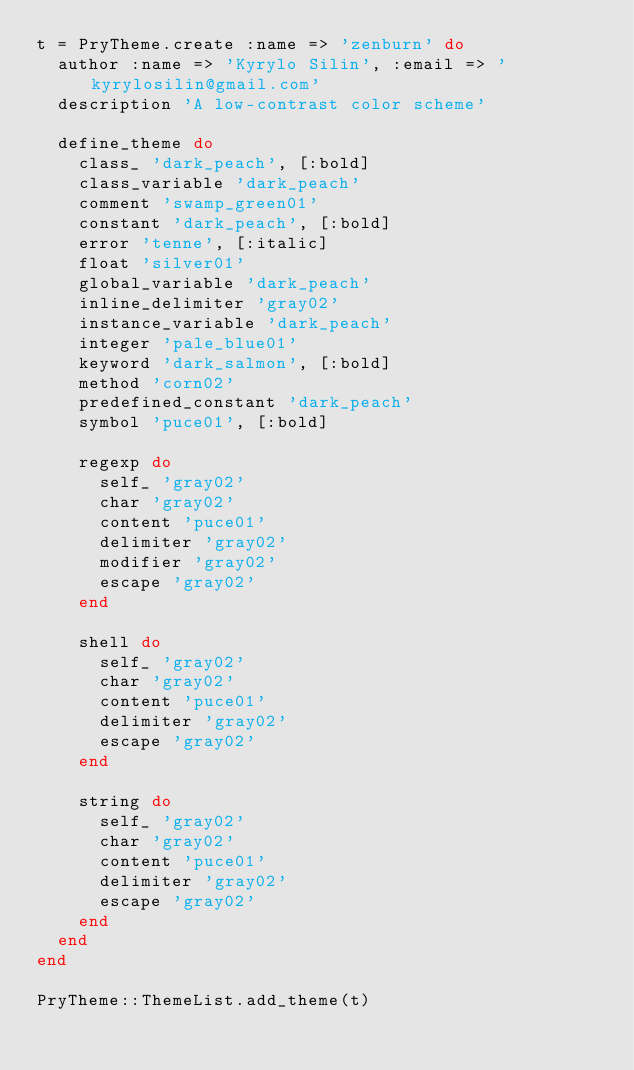<code> <loc_0><loc_0><loc_500><loc_500><_Ruby_>t = PryTheme.create :name => 'zenburn' do
  author :name => 'Kyrylo Silin', :email => 'kyrylosilin@gmail.com'
  description 'A low-contrast color scheme'

  define_theme do
    class_ 'dark_peach', [:bold]
    class_variable 'dark_peach'
    comment 'swamp_green01'
    constant 'dark_peach', [:bold]
    error 'tenne', [:italic]
    float 'silver01'
    global_variable 'dark_peach'
    inline_delimiter 'gray02'
    instance_variable 'dark_peach'
    integer 'pale_blue01'
    keyword 'dark_salmon', [:bold]
    method 'corn02'
    predefined_constant 'dark_peach'
    symbol 'puce01', [:bold]

    regexp do
      self_ 'gray02'
      char 'gray02'
      content 'puce01'
      delimiter 'gray02'
      modifier 'gray02'
      escape 'gray02'
    end

    shell do
      self_ 'gray02'
      char 'gray02'
      content 'puce01'
      delimiter 'gray02'
      escape 'gray02'
    end

    string do
      self_ 'gray02'
      char 'gray02'
      content 'puce01'
      delimiter 'gray02'
      escape 'gray02'
    end
  end
end

PryTheme::ThemeList.add_theme(t)
</code> 